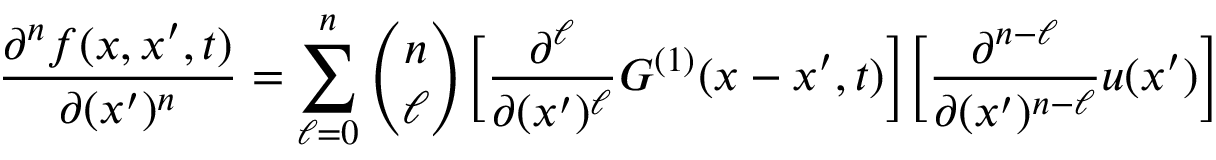<formula> <loc_0><loc_0><loc_500><loc_500>\frac { \partial ^ { n } f ( x , x ^ { \prime } , t ) } { \partial ( x ^ { \prime } ) ^ { n } } = \sum _ { \ell = 0 } ^ { n } \binom { n } { \ell } \left [ \frac { \partial ^ { \ell } } { \partial ( x ^ { \prime } ) ^ { \ell } } G ^ { ( 1 ) } ( x - x ^ { \prime } , t ) \right ] \left [ \frac { \partial ^ { n - \ell } } { \partial ( x ^ { \prime } ) ^ { n - \ell } } u ( x ^ { \prime } ) \right ]</formula> 